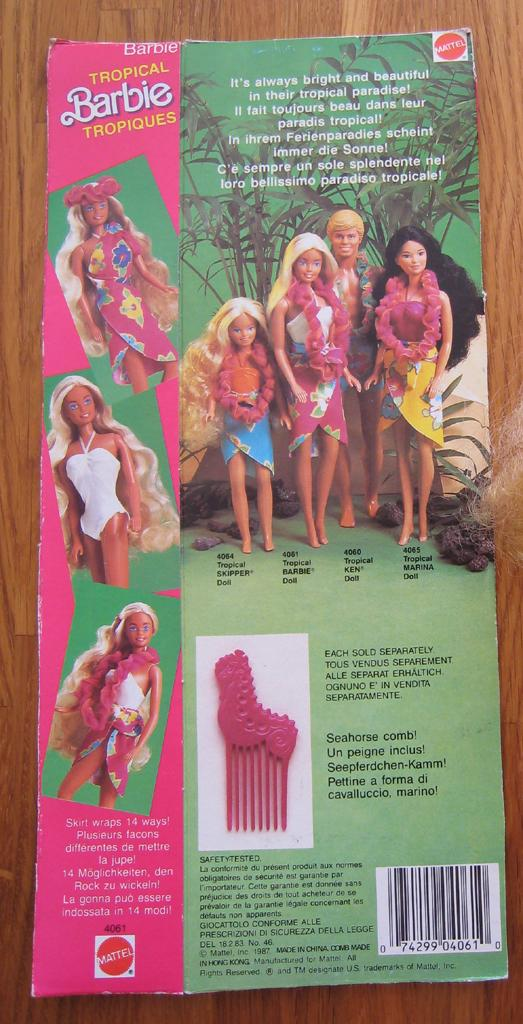What is present on the table in the image? There is a paper on the table in the image. What is the content of the paper? The paper contains text and depictions of people. How many cherries are on the table in the image? There are no cherries present in the image. What type of bee can be seen buzzing around the paper in the image? There are no bees present in the image. 